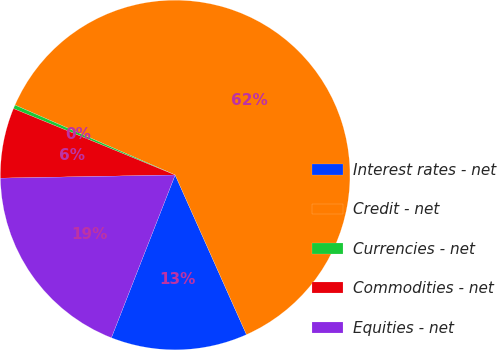<chart> <loc_0><loc_0><loc_500><loc_500><pie_chart><fcel>Interest rates - net<fcel>Credit - net<fcel>Currencies - net<fcel>Commodities - net<fcel>Equities - net<nl><fcel>12.63%<fcel>61.76%<fcel>0.35%<fcel>6.49%<fcel>18.77%<nl></chart> 